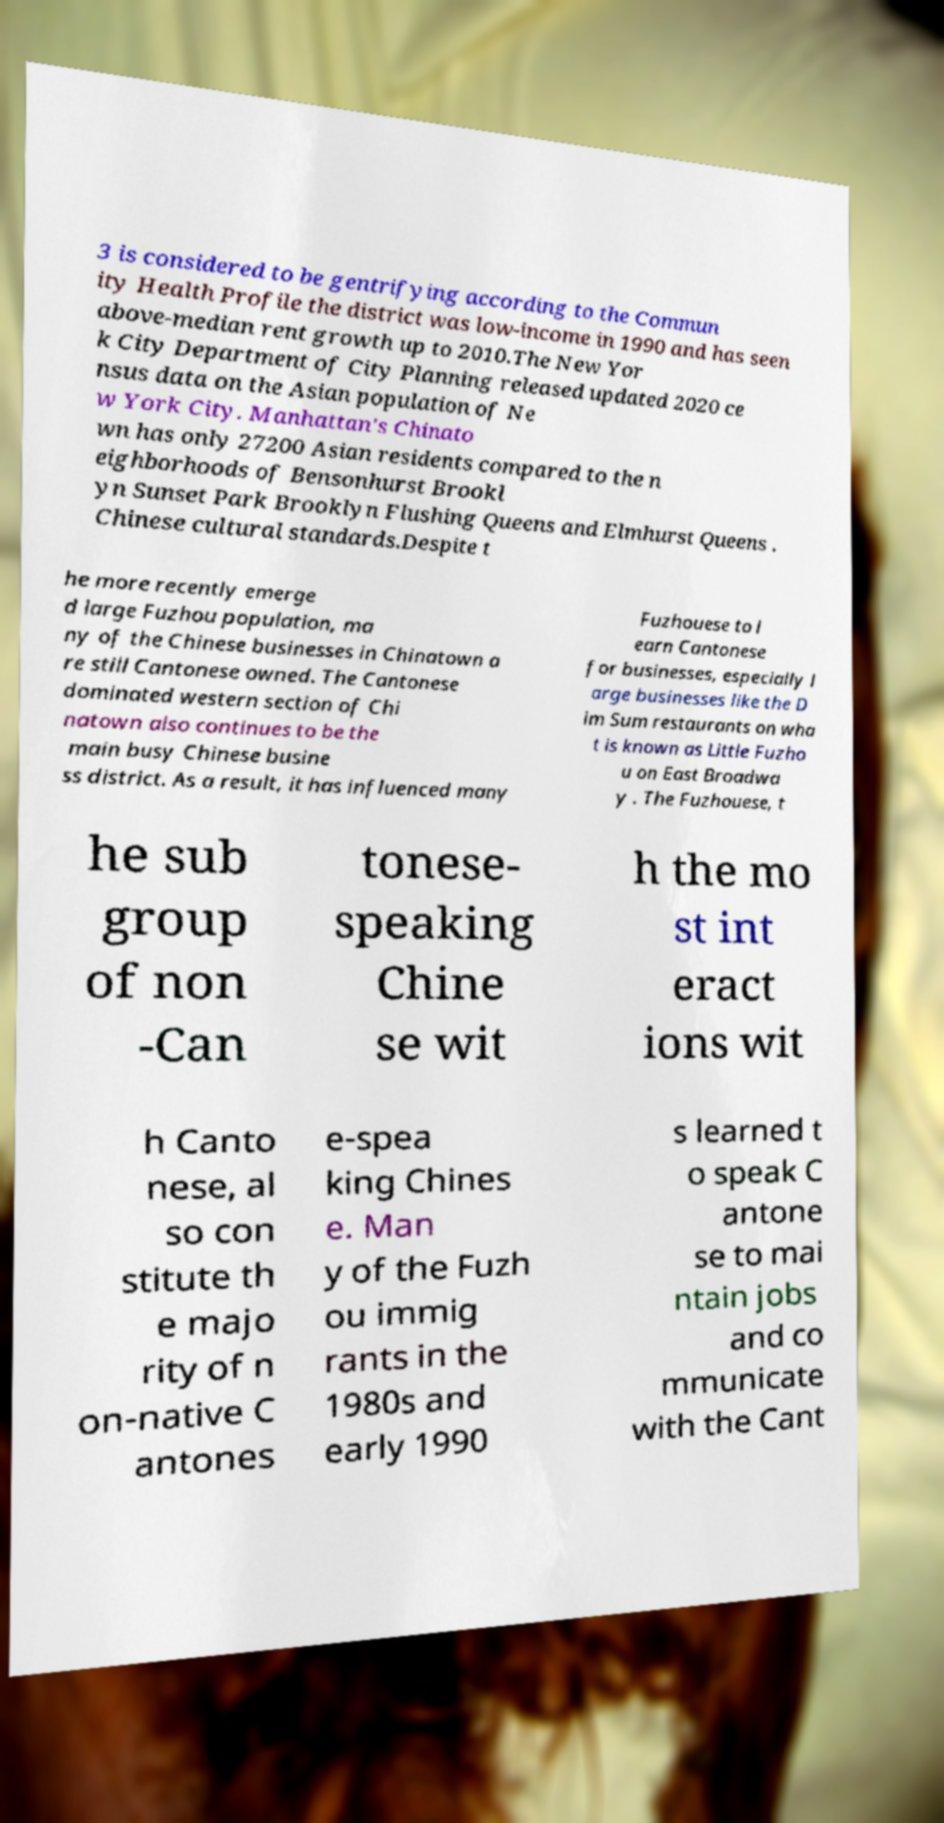There's text embedded in this image that I need extracted. Can you transcribe it verbatim? 3 is considered to be gentrifying according to the Commun ity Health Profile the district was low-income in 1990 and has seen above-median rent growth up to 2010.The New Yor k City Department of City Planning released updated 2020 ce nsus data on the Asian population of Ne w York City. Manhattan's Chinato wn has only 27200 Asian residents compared to the n eighborhoods of Bensonhurst Brookl yn Sunset Park Brooklyn Flushing Queens and Elmhurst Queens . Chinese cultural standards.Despite t he more recently emerge d large Fuzhou population, ma ny of the Chinese businesses in Chinatown a re still Cantonese owned. The Cantonese dominated western section of Chi natown also continues to be the main busy Chinese busine ss district. As a result, it has influenced many Fuzhouese to l earn Cantonese for businesses, especially l arge businesses like the D im Sum restaurants on wha t is known as Little Fuzho u on East Broadwa y . The Fuzhouese, t he sub group of non -Can tonese- speaking Chine se wit h the mo st int eract ions wit h Canto nese, al so con stitute th e majo rity of n on-native C antones e-spea king Chines e. Man y of the Fuzh ou immig rants in the 1980s and early 1990 s learned t o speak C antone se to mai ntain jobs and co mmunicate with the Cant 